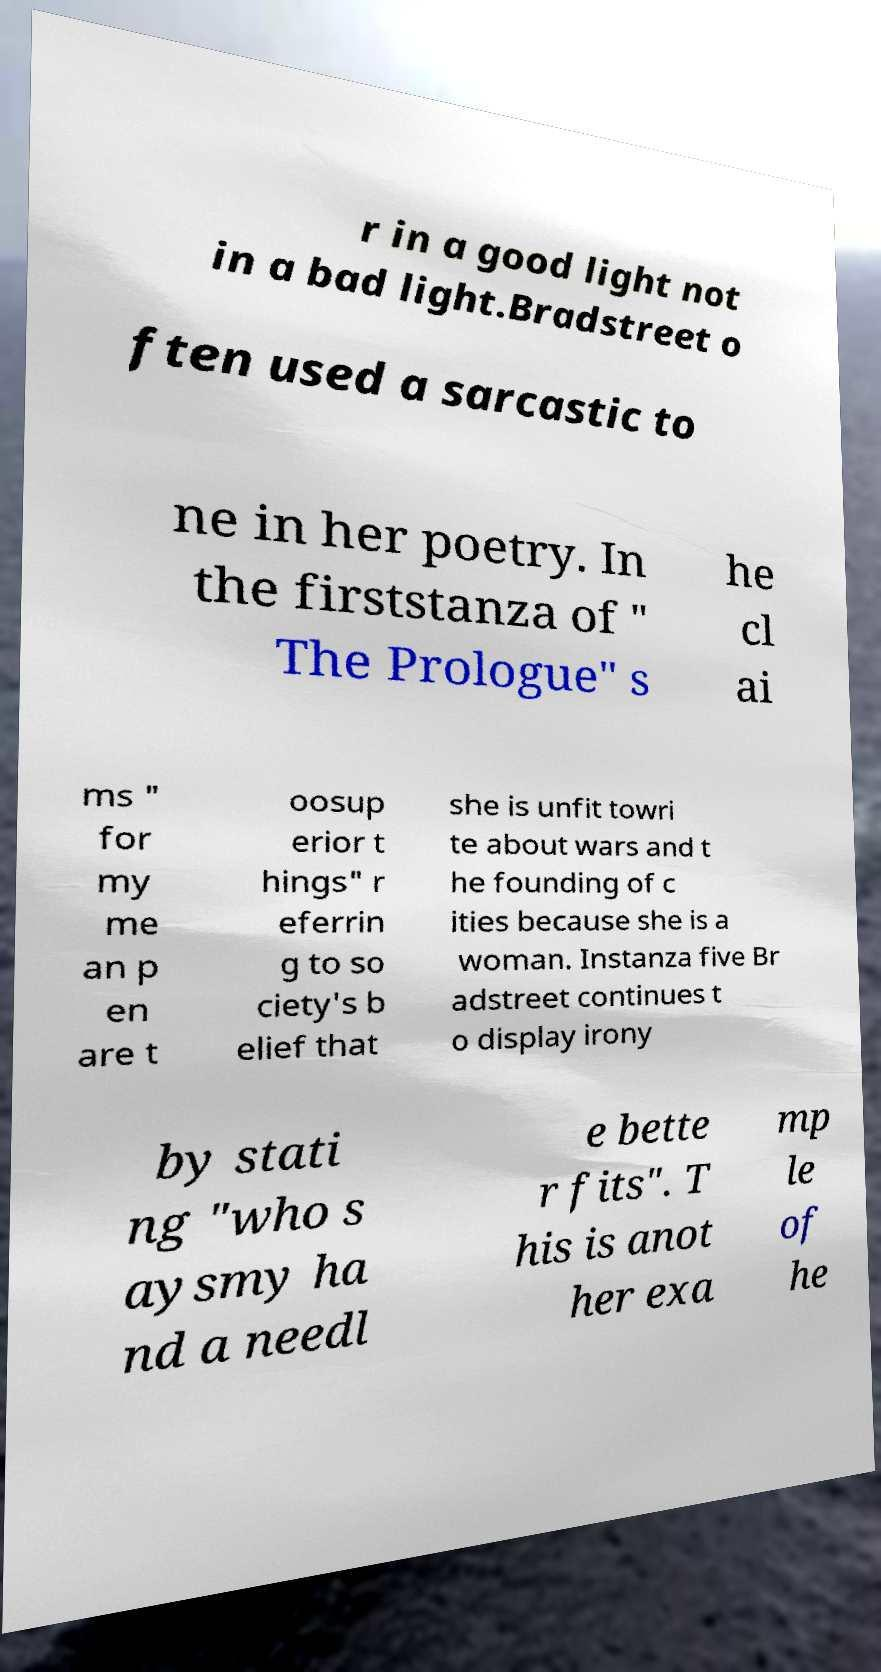There's text embedded in this image that I need extracted. Can you transcribe it verbatim? r in a good light not in a bad light.Bradstreet o ften used a sarcastic to ne in her poetry. In the firststanza of " The Prologue" s he cl ai ms " for my me an p en are t oosup erior t hings" r eferrin g to so ciety's b elief that she is unfit towri te about wars and t he founding of c ities because she is a woman. Instanza five Br adstreet continues t o display irony by stati ng "who s aysmy ha nd a needl e bette r fits". T his is anot her exa mp le of he 